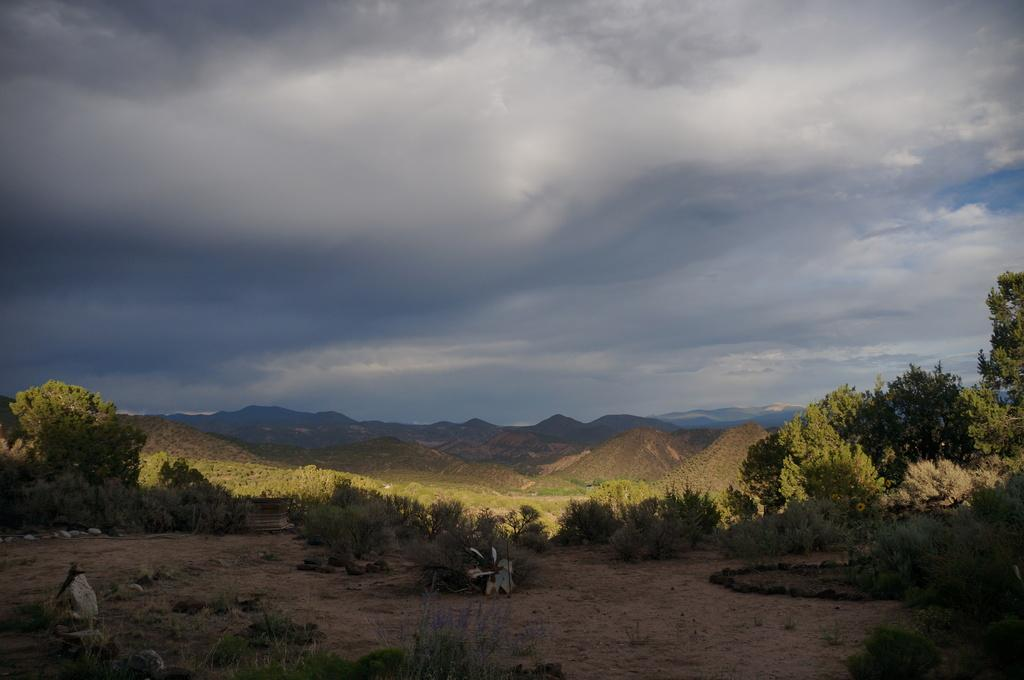What type of vegetation can be seen in the image? There are plants and trees in the image. Where are the plants and trees located? The plants and trees are on the land in the image. What can be seen in the background of the image? There are hills in the background of the image. What is visible at the top of the image? The sky is visible at the top of the image. What other natural elements can be seen in the image? There are rocks and grass on the land in the image. Can you see a cub playing with a yoke in the image? There is no cub or yoke present in the image; it features plants, trees, hills, sky, rocks, and grass. 